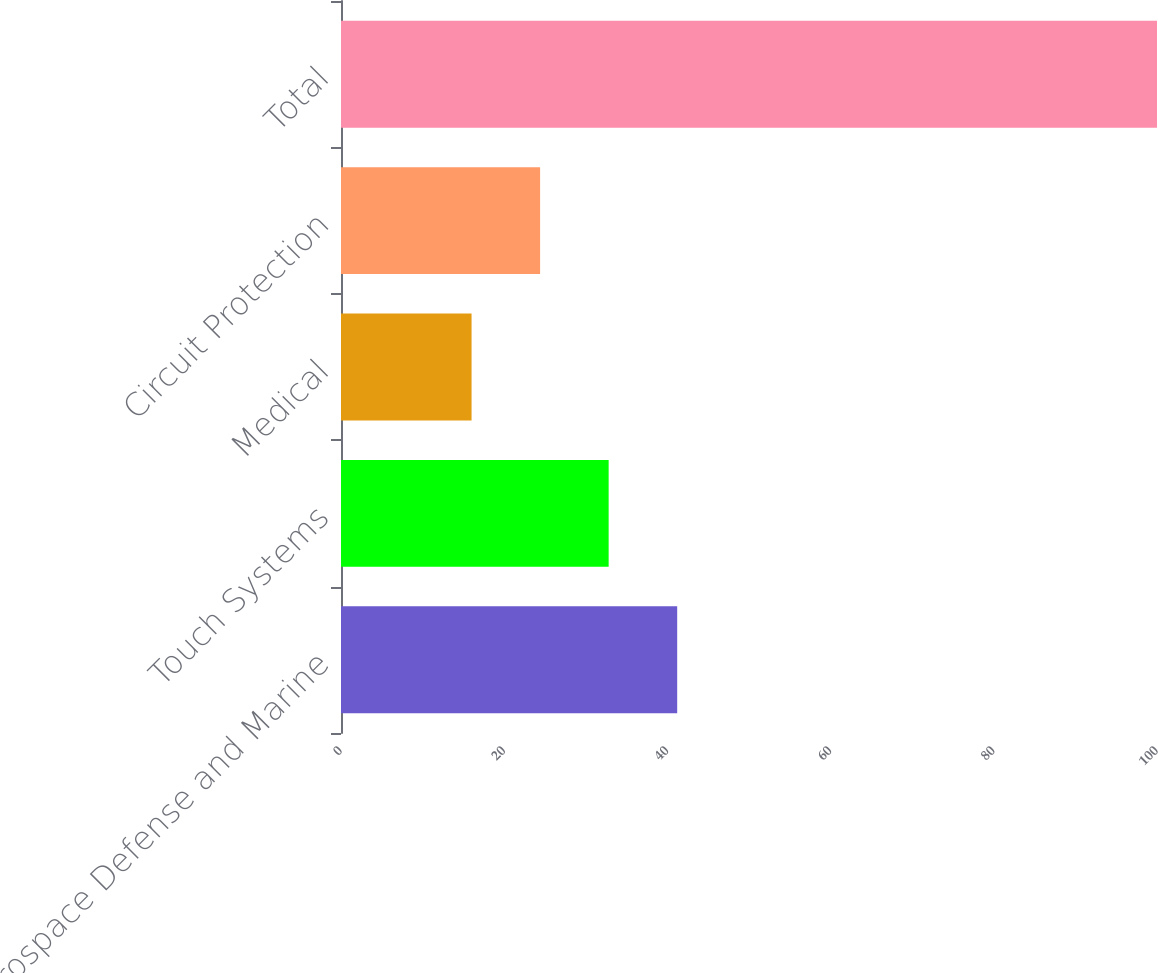Convert chart. <chart><loc_0><loc_0><loc_500><loc_500><bar_chart><fcel>Aerospace Defense and Marine<fcel>Touch Systems<fcel>Medical<fcel>Circuit Protection<fcel>Total<nl><fcel>41.2<fcel>32.8<fcel>16<fcel>24.4<fcel>100<nl></chart> 